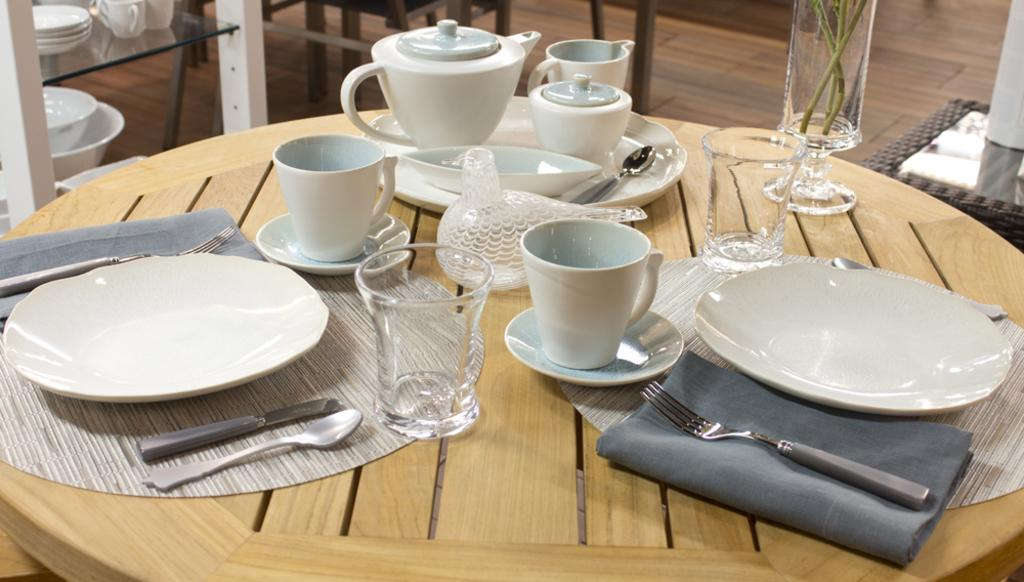What piece of furniture is present in the image? There is a table in the image. What items are placed on the table? There are plates, cups, a glass, and spoons on the table. How many types of tableware can be seen in the image? There are three types of tableware: plates, cups, and spoons. Who is the coach sitting next to the table in the image? There is no coach present in the image; it only shows a table with plates, cups, a glass, and spoons on it. 